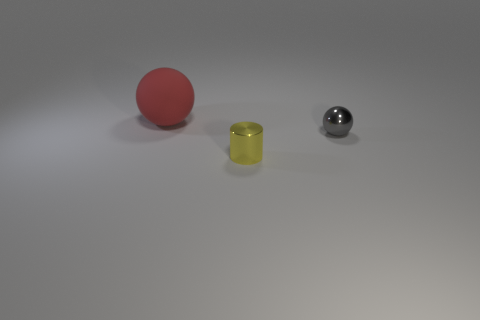Add 3 big yellow matte balls. How many objects exist? 6 Subtract all cylinders. How many objects are left? 2 Subtract all big red balls. Subtract all tiny gray things. How many objects are left? 1 Add 3 large red rubber balls. How many large red rubber balls are left? 4 Add 3 big spheres. How many big spheres exist? 4 Subtract 0 blue cylinders. How many objects are left? 3 